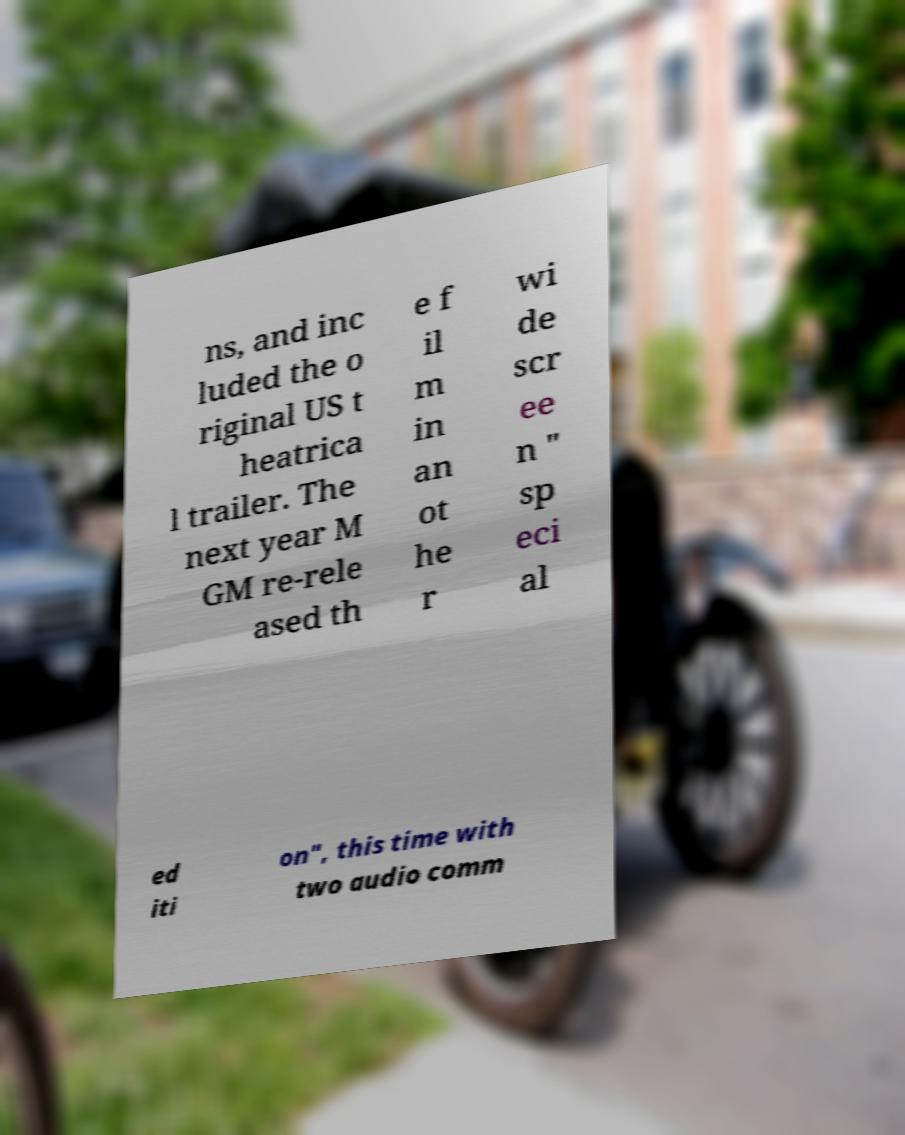I need the written content from this picture converted into text. Can you do that? ns, and inc luded the o riginal US t heatrica l trailer. The next year M GM re-rele ased th e f il m in an ot he r wi de scr ee n " sp eci al ed iti on", this time with two audio comm 